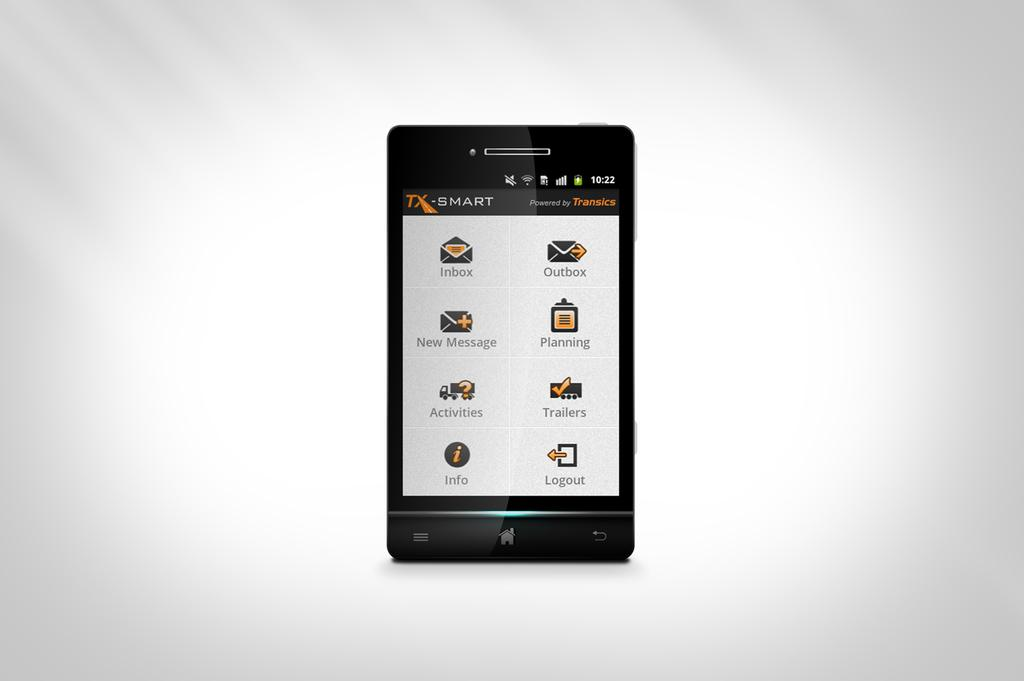Provide a one-sentence caption for the provided image. The Smart device has eight icons, including inbox and messaging. 